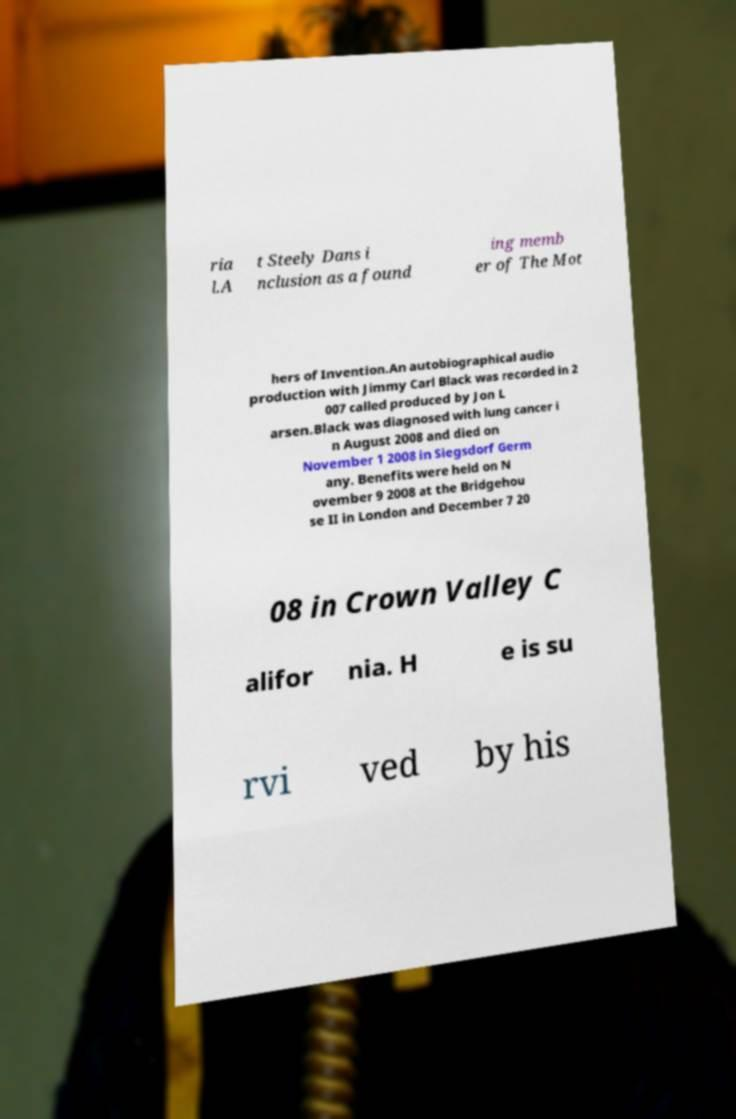Please read and relay the text visible in this image. What does it say? ria l.A t Steely Dans i nclusion as a found ing memb er of The Mot hers of Invention.An autobiographical audio production with Jimmy Carl Black was recorded in 2 007 called produced by Jon L arsen.Black was diagnosed with lung cancer i n August 2008 and died on November 1 2008 in Siegsdorf Germ any. Benefits were held on N ovember 9 2008 at the Bridgehou se II in London and December 7 20 08 in Crown Valley C alifor nia. H e is su rvi ved by his 